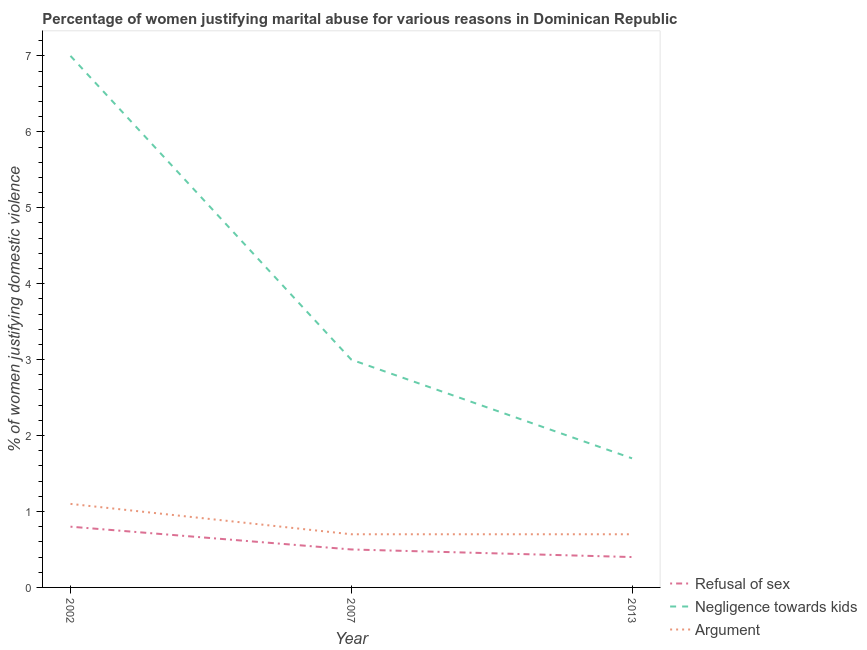How many different coloured lines are there?
Offer a very short reply. 3. What is the percentage of women justifying domestic violence due to negligence towards kids in 2007?
Keep it short and to the point. 3. Across all years, what is the minimum percentage of women justifying domestic violence due to negligence towards kids?
Offer a terse response. 1.7. In which year was the percentage of women justifying domestic violence due to negligence towards kids maximum?
Give a very brief answer. 2002. What is the total percentage of women justifying domestic violence due to refusal of sex in the graph?
Keep it short and to the point. 1.7. What is the difference between the percentage of women justifying domestic violence due to negligence towards kids in 2002 and that in 2007?
Your response must be concise. 4. What is the difference between the percentage of women justifying domestic violence due to negligence towards kids in 2013 and the percentage of women justifying domestic violence due to arguments in 2002?
Provide a short and direct response. 0.6. What is the average percentage of women justifying domestic violence due to negligence towards kids per year?
Ensure brevity in your answer.  3.9. In the year 2007, what is the difference between the percentage of women justifying domestic violence due to refusal of sex and percentage of women justifying domestic violence due to negligence towards kids?
Offer a terse response. -2.5. In how many years, is the percentage of women justifying domestic violence due to negligence towards kids greater than 5 %?
Your answer should be compact. 1. What is the ratio of the percentage of women justifying domestic violence due to arguments in 2007 to that in 2013?
Your answer should be very brief. 1. Is the difference between the percentage of women justifying domestic violence due to refusal of sex in 2002 and 2007 greater than the difference between the percentage of women justifying domestic violence due to arguments in 2002 and 2007?
Offer a terse response. No. What is the difference between the highest and the second highest percentage of women justifying domestic violence due to negligence towards kids?
Make the answer very short. 4. In how many years, is the percentage of women justifying domestic violence due to arguments greater than the average percentage of women justifying domestic violence due to arguments taken over all years?
Provide a short and direct response. 1. Is it the case that in every year, the sum of the percentage of women justifying domestic violence due to refusal of sex and percentage of women justifying domestic violence due to negligence towards kids is greater than the percentage of women justifying domestic violence due to arguments?
Your answer should be very brief. Yes. Does the percentage of women justifying domestic violence due to arguments monotonically increase over the years?
Give a very brief answer. No. Is the percentage of women justifying domestic violence due to negligence towards kids strictly less than the percentage of women justifying domestic violence due to refusal of sex over the years?
Keep it short and to the point. No. How many lines are there?
Make the answer very short. 3. Does the graph contain grids?
Ensure brevity in your answer.  No. How are the legend labels stacked?
Offer a very short reply. Vertical. What is the title of the graph?
Keep it short and to the point. Percentage of women justifying marital abuse for various reasons in Dominican Republic. What is the label or title of the X-axis?
Your answer should be compact. Year. What is the label or title of the Y-axis?
Offer a terse response. % of women justifying domestic violence. What is the % of women justifying domestic violence in Refusal of sex in 2002?
Your answer should be compact. 0.8. What is the % of women justifying domestic violence in Negligence towards kids in 2002?
Your answer should be compact. 7. What is the % of women justifying domestic violence in Negligence towards kids in 2007?
Your answer should be compact. 3. What is the % of women justifying domestic violence in Negligence towards kids in 2013?
Your response must be concise. 1.7. Across all years, what is the minimum % of women justifying domestic violence in Refusal of sex?
Your answer should be very brief. 0.4. Across all years, what is the minimum % of women justifying domestic violence of Negligence towards kids?
Your answer should be very brief. 1.7. Across all years, what is the minimum % of women justifying domestic violence of Argument?
Provide a succinct answer. 0.7. What is the total % of women justifying domestic violence of Negligence towards kids in the graph?
Keep it short and to the point. 11.7. What is the total % of women justifying domestic violence of Argument in the graph?
Give a very brief answer. 2.5. What is the difference between the % of women justifying domestic violence of Negligence towards kids in 2002 and that in 2007?
Offer a terse response. 4. What is the difference between the % of women justifying domestic violence of Argument in 2002 and that in 2007?
Offer a terse response. 0.4. What is the difference between the % of women justifying domestic violence of Refusal of sex in 2007 and that in 2013?
Give a very brief answer. 0.1. What is the difference between the % of women justifying domestic violence of Negligence towards kids in 2002 and the % of women justifying domestic violence of Argument in 2007?
Provide a short and direct response. 6.3. What is the difference between the % of women justifying domestic violence in Refusal of sex in 2002 and the % of women justifying domestic violence in Argument in 2013?
Keep it short and to the point. 0.1. What is the difference between the % of women justifying domestic violence in Negligence towards kids in 2002 and the % of women justifying domestic violence in Argument in 2013?
Your answer should be compact. 6.3. What is the difference between the % of women justifying domestic violence in Refusal of sex in 2007 and the % of women justifying domestic violence in Negligence towards kids in 2013?
Offer a very short reply. -1.2. What is the difference between the % of women justifying domestic violence in Refusal of sex in 2007 and the % of women justifying domestic violence in Argument in 2013?
Keep it short and to the point. -0.2. What is the average % of women justifying domestic violence of Refusal of sex per year?
Your answer should be very brief. 0.57. In the year 2002, what is the difference between the % of women justifying domestic violence in Negligence towards kids and % of women justifying domestic violence in Argument?
Offer a very short reply. 5.9. In the year 2007, what is the difference between the % of women justifying domestic violence of Negligence towards kids and % of women justifying domestic violence of Argument?
Your answer should be compact. 2.3. In the year 2013, what is the difference between the % of women justifying domestic violence in Negligence towards kids and % of women justifying domestic violence in Argument?
Your answer should be compact. 1. What is the ratio of the % of women justifying domestic violence of Negligence towards kids in 2002 to that in 2007?
Make the answer very short. 2.33. What is the ratio of the % of women justifying domestic violence of Argument in 2002 to that in 2007?
Make the answer very short. 1.57. What is the ratio of the % of women justifying domestic violence of Refusal of sex in 2002 to that in 2013?
Provide a short and direct response. 2. What is the ratio of the % of women justifying domestic violence in Negligence towards kids in 2002 to that in 2013?
Offer a very short reply. 4.12. What is the ratio of the % of women justifying domestic violence of Argument in 2002 to that in 2013?
Your answer should be compact. 1.57. What is the ratio of the % of women justifying domestic violence of Refusal of sex in 2007 to that in 2013?
Give a very brief answer. 1.25. What is the ratio of the % of women justifying domestic violence of Negligence towards kids in 2007 to that in 2013?
Offer a terse response. 1.76. What is the difference between the highest and the lowest % of women justifying domestic violence of Negligence towards kids?
Provide a succinct answer. 5.3. What is the difference between the highest and the lowest % of women justifying domestic violence in Argument?
Provide a succinct answer. 0.4. 